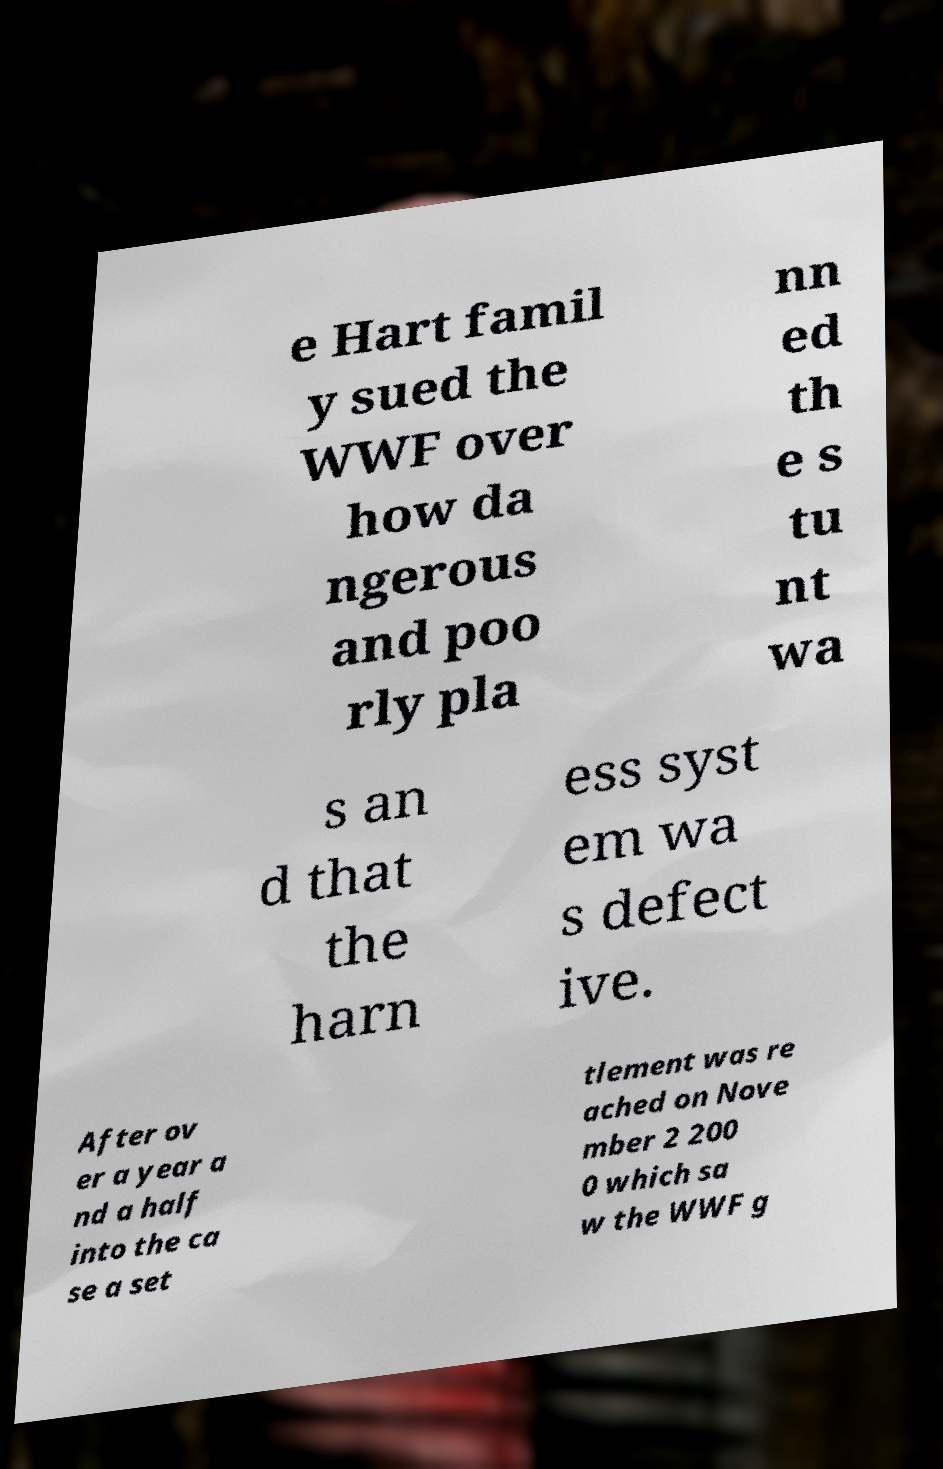Please identify and transcribe the text found in this image. e Hart famil y sued the WWF over how da ngerous and poo rly pla nn ed th e s tu nt wa s an d that the harn ess syst em wa s defect ive. After ov er a year a nd a half into the ca se a set tlement was re ached on Nove mber 2 200 0 which sa w the WWF g 